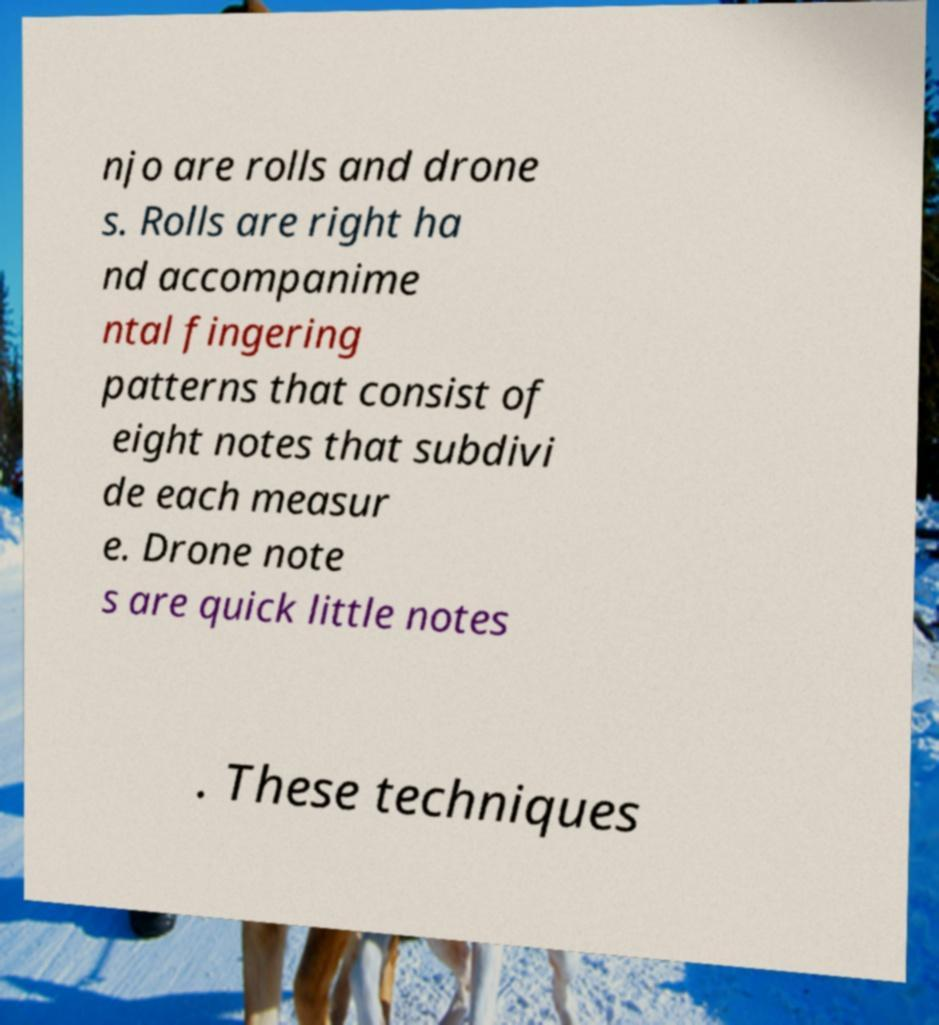Can you accurately transcribe the text from the provided image for me? njo are rolls and drone s. Rolls are right ha nd accompanime ntal fingering patterns that consist of eight notes that subdivi de each measur e. Drone note s are quick little notes . These techniques 